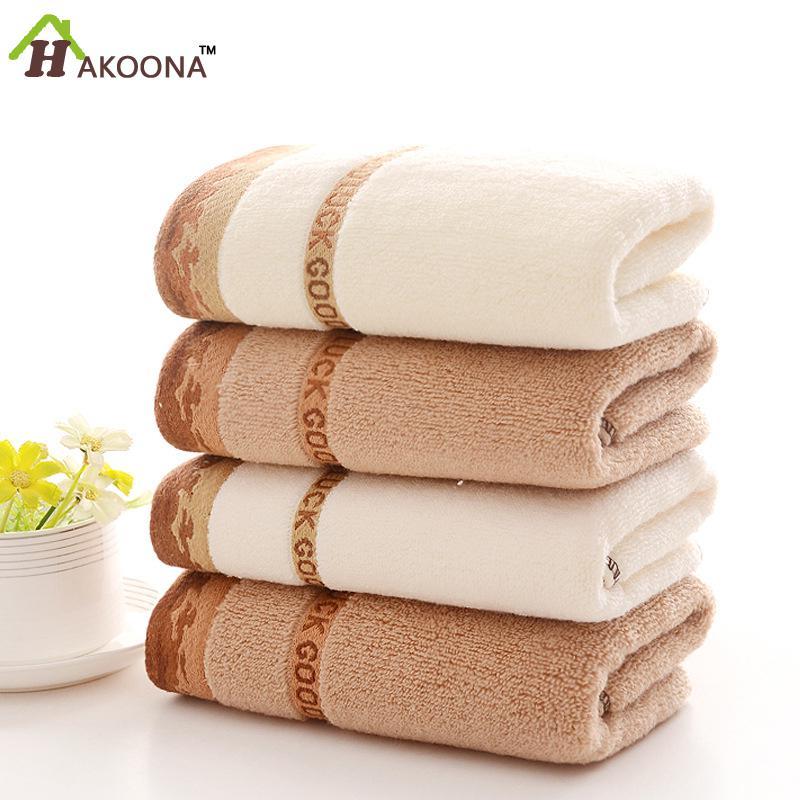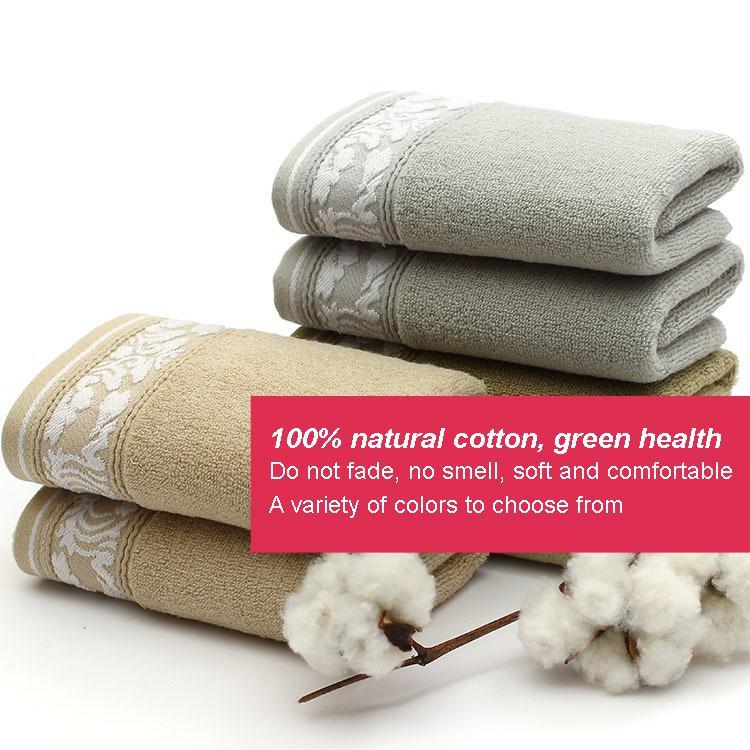The first image is the image on the left, the second image is the image on the right. Given the left and right images, does the statement "There are three folded towels on the right image." hold true? Answer yes or no. No. 